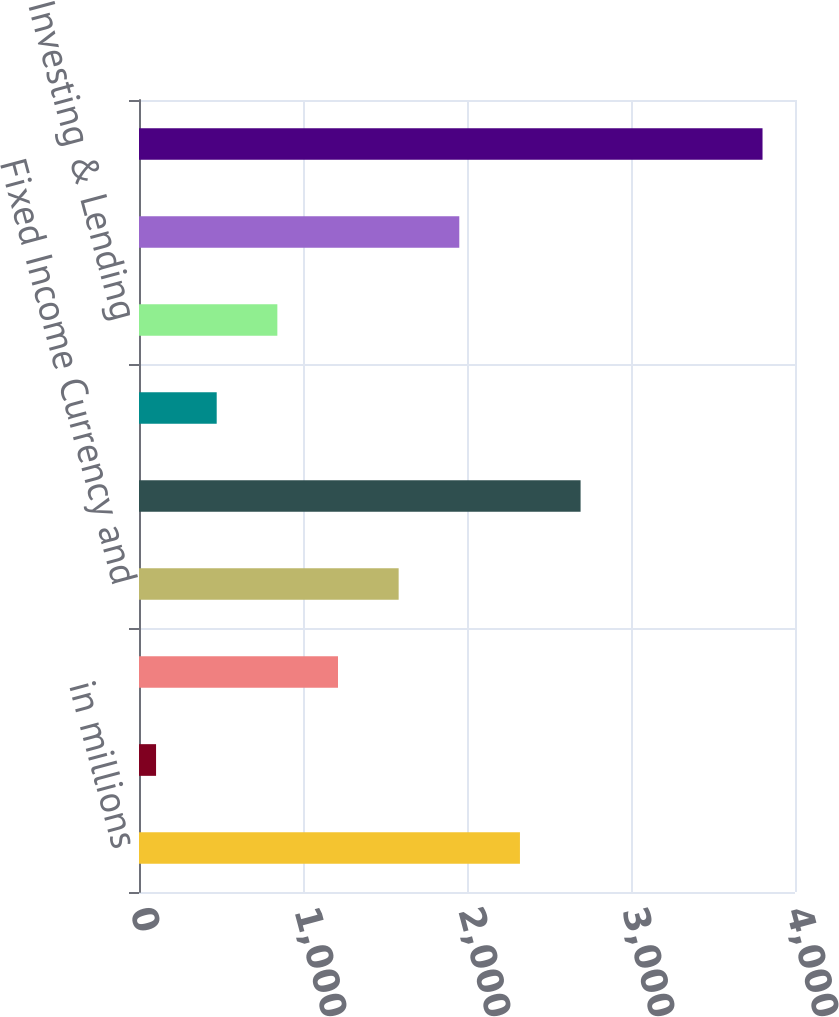<chart> <loc_0><loc_0><loc_500><loc_500><bar_chart><fcel>in millions<fcel>Financial Advisory<fcel>Underwriting<fcel>Fixed Income Currency and<fcel>Equities Client Execution<fcel>Securities Services<fcel>Investing & Lending<fcel>Investment Management<fcel>Total<nl><fcel>2322.8<fcel>104<fcel>1213.4<fcel>1583.2<fcel>2692.6<fcel>473.8<fcel>843.6<fcel>1953<fcel>3802<nl></chart> 